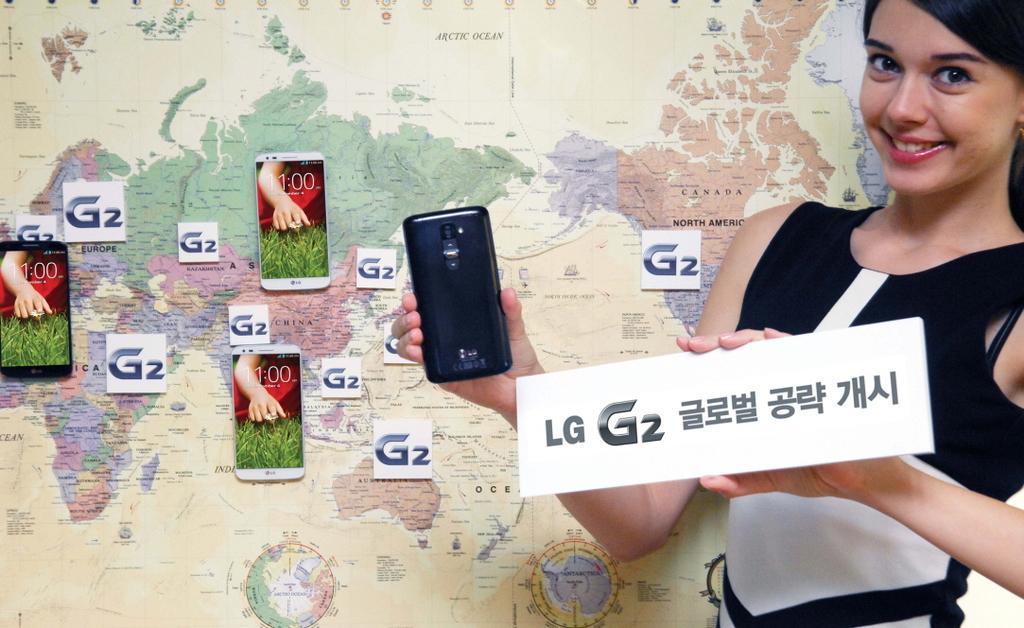How would you summarize this image in a sentence or two? There is a woman standing in front of map and holding a mobile phone and LG sticker. Behind her there are mobile phones and stickers stick on wall. 